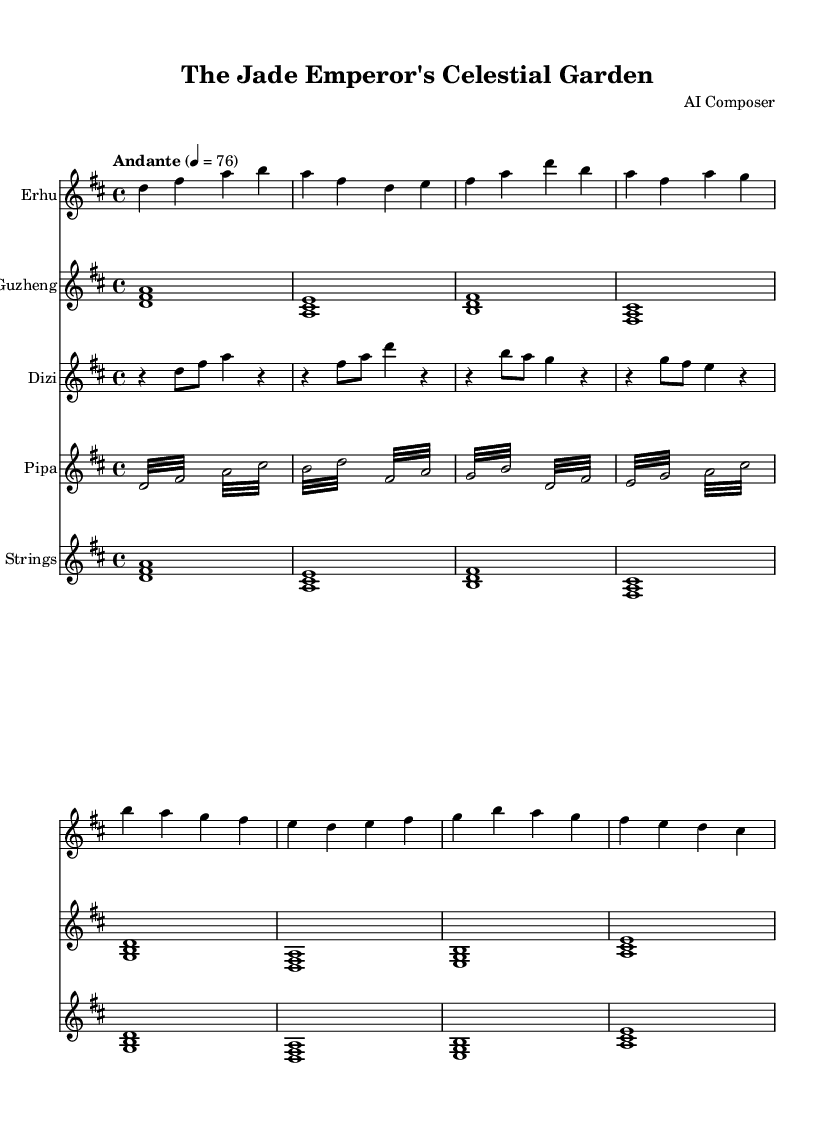What is the key signature of this music? The key signature is indicated at the beginning of the sheet music, which shows two sharps (F# and C#). Hence, the key signature corresponds to D major.
Answer: D major What is the time signature of this music? The time signature is displayed at the beginning, showing four beats per measure, represented as 4/4 time.
Answer: 4/4 What is the tempo marking of this music? The tempo is indicated in the header section, which specifies "Andante" at a tempo of quarter note = 76.
Answer: Andante How many different instruments are used in this composition? By counting the number of different staves shown in the score, there are five instruments: Erhu, Guzheng, Dizi, Pipa, and Strings.
Answer: Five Which instrument features a tremolo technique in its part? The Pipa portion shows repeated rapid notes described by the term "tremolo," indicating this technique is utilized for the Pipa.
Answer: Pipa What is the first note played by the Guzheng? Looking at the Guzheng staff, the first note is a D, which is played as a chord with F# and A.
Answer: D What note is played last in the Erhu part? The last note in the Erhu part is E, as seen at the end of the staff for that instrument.
Answer: E 